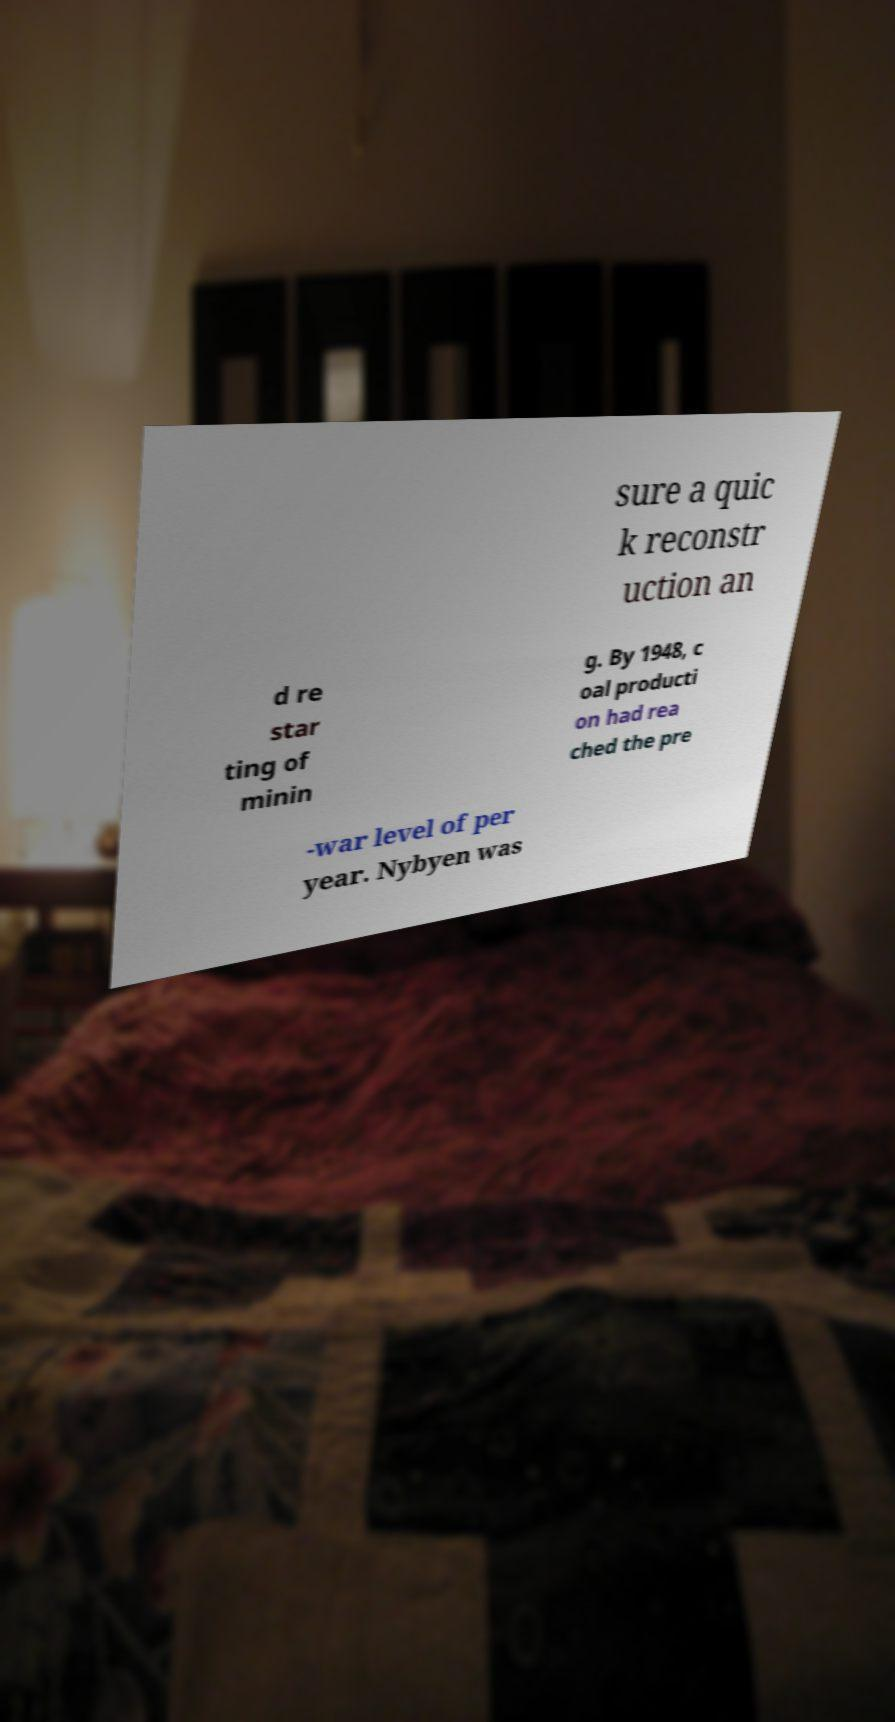Could you extract and type out the text from this image? sure a quic k reconstr uction an d re star ting of minin g. By 1948, c oal producti on had rea ched the pre -war level of per year. Nybyen was 